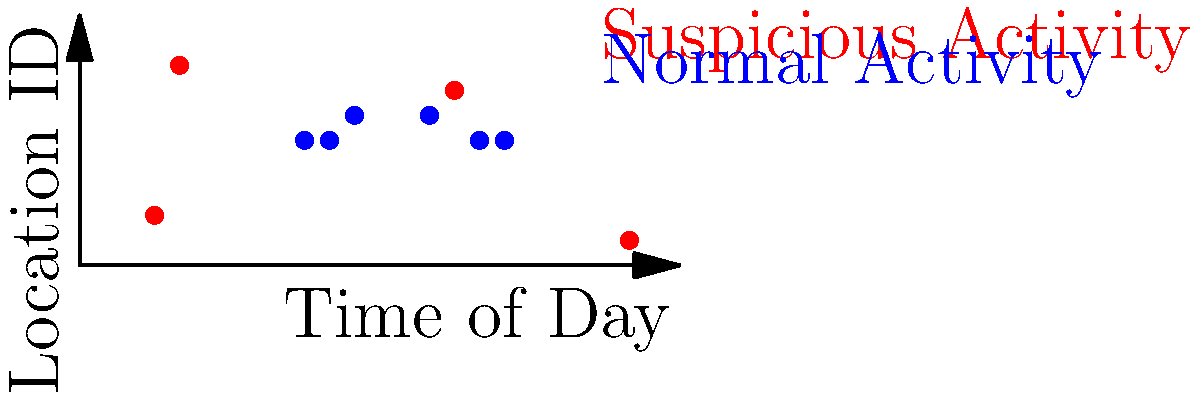Based on the scatter plot of login times and locations, which time period shows the highest concentration of suspicious user activity? To identify the time period with the highest concentration of suspicious user activity, we need to analyze the red dots on the scatter plot, which represent suspicious activity. Let's break it down step-by-step:

1. Observe the red dots on the plot:
   - There are four red dots at approximately (3,2), (4,8), (15,7), and (22,1)

2. Group the dots by time periods:
   - Early morning (0-6): 2 dots
   - Morning to afternoon (6-12): 0 dots
   - Afternoon to evening (12-18): 1 dot
   - Late evening to night (18-24): 1 dot

3. Identify the period with the most red dots:
   - The early morning period (0-6) has the highest number of suspicious activity points with 2 dots.

4. Consider the time proximity:
   - The two suspicious activities in the early morning are close in time (around 3 AM and 4 AM), indicating a concentrated period of suspicious activity.

5. Compare with normal activity:
   - Note that there are no blue dots (normal activity) during this early morning period, which further highlights the suspiciousness of these logins.

Based on this analysis, we can conclude that the early morning hours, specifically between 3 AM and 4 AM, show the highest concentration of suspicious user activity.
Answer: Early morning (3-4 AM) 